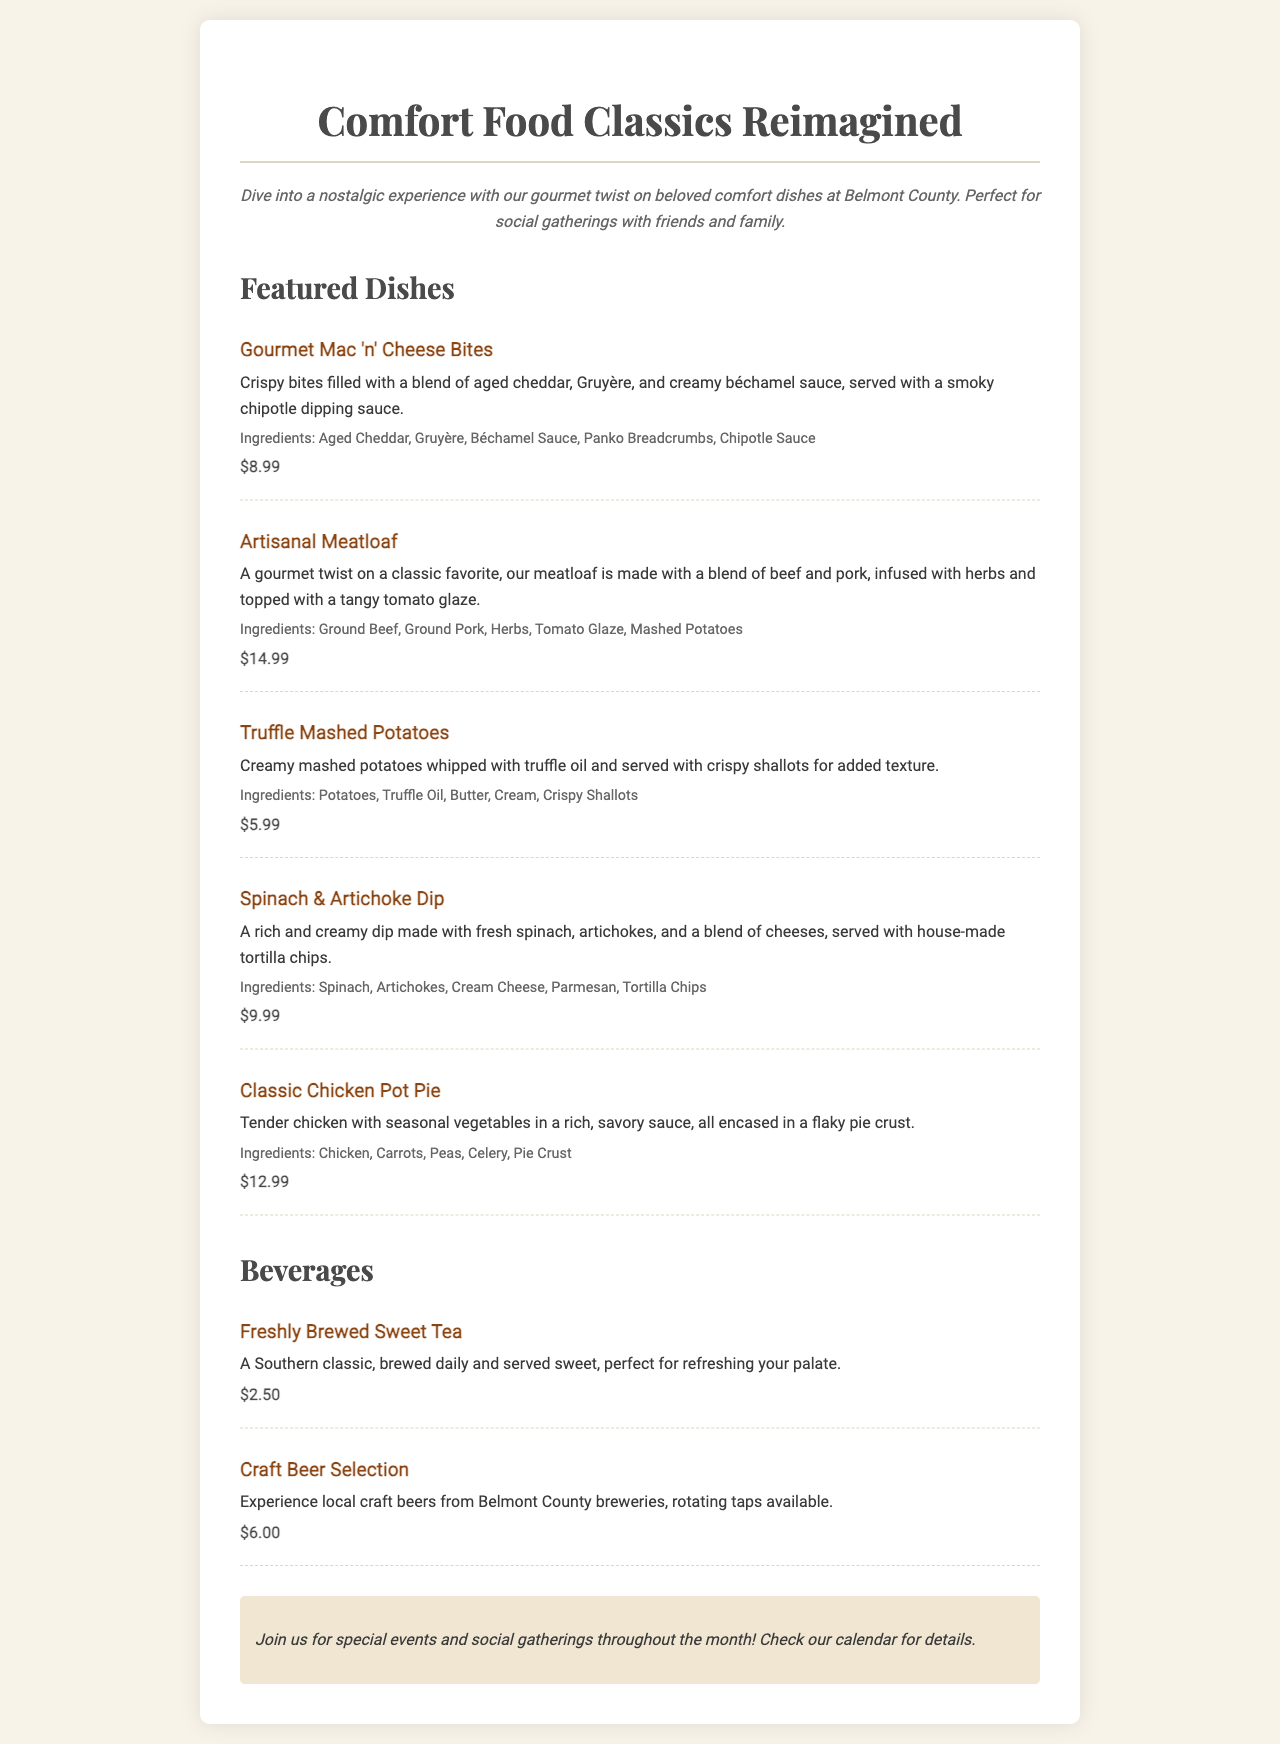what is the price of Gourmet Mac 'n' Cheese Bites? The price for Gourmet Mac 'n' Cheese Bites is specified in the menu section, which is $8.99.
Answer: $8.99 what dish contains a blend of beef and pork? The dish that contains a blend of beef and pork is the Artisanal Meatloaf, as described in the menu.
Answer: Artisanal Meatloaf which beverage is a Southern classic? The beverage described as a Southern classic in the menu is Freshly Brewed Sweet Tea.
Answer: Freshly Brewed Sweet Tea how many ingredients are listed for Spinach & Artichoke Dip? The number of ingredients listed for Spinach & Artichoke Dip can be counted in the ingredients section, which lists five ingredients.
Answer: 5 what is the recommended use for the Comfort Food Classics menu? The recommended use for the menu is for social gatherings with friends and family, mentioned in the description.
Answer: social gatherings what is served with the Truffle Mashed Potatoes? The menu states that the Truffle Mashed Potatoes are served with crispy shallots for added texture.
Answer: crispy shallots 